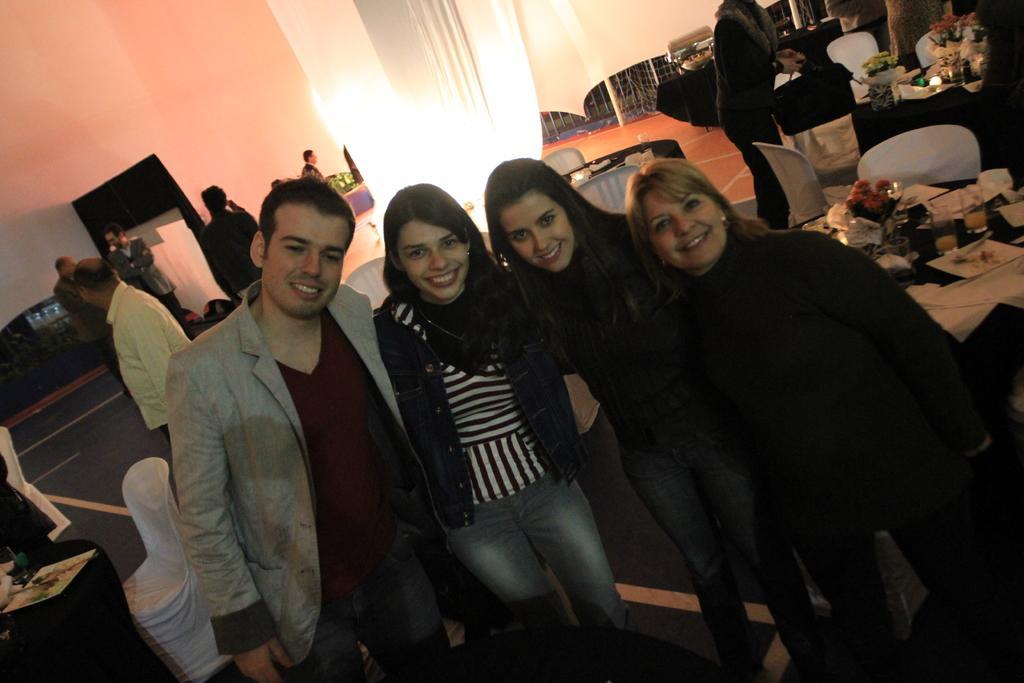Can you describe this image briefly? In this image I can see number of people are standing. I can see most of them are wearing jackets. Here I can see smile on few faces. In the background I can see few chairs, few tables and on these tables I can see number of flowers. 